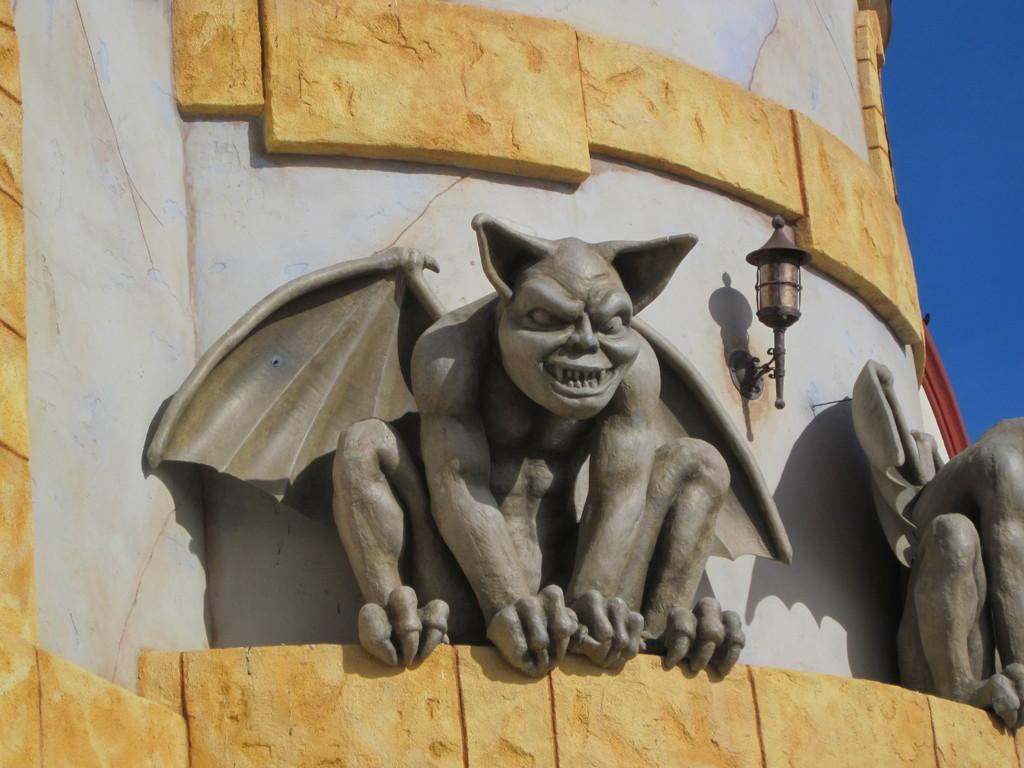What type of art is present in the image? There are sculptures in the image. What other objects can be seen in the image? There is a street lamp attached to a building. What part of the natural environment is visible in the image? The sky is visible in the top right corner of the image. What type of lace can be seen on the sculptures in the image? There is no lace present on the sculptures in the image. How does the bubble affect the appearance of the street lamp in the image? There is no bubble present in the image, so it does not affect the appearance of the street lamp. 